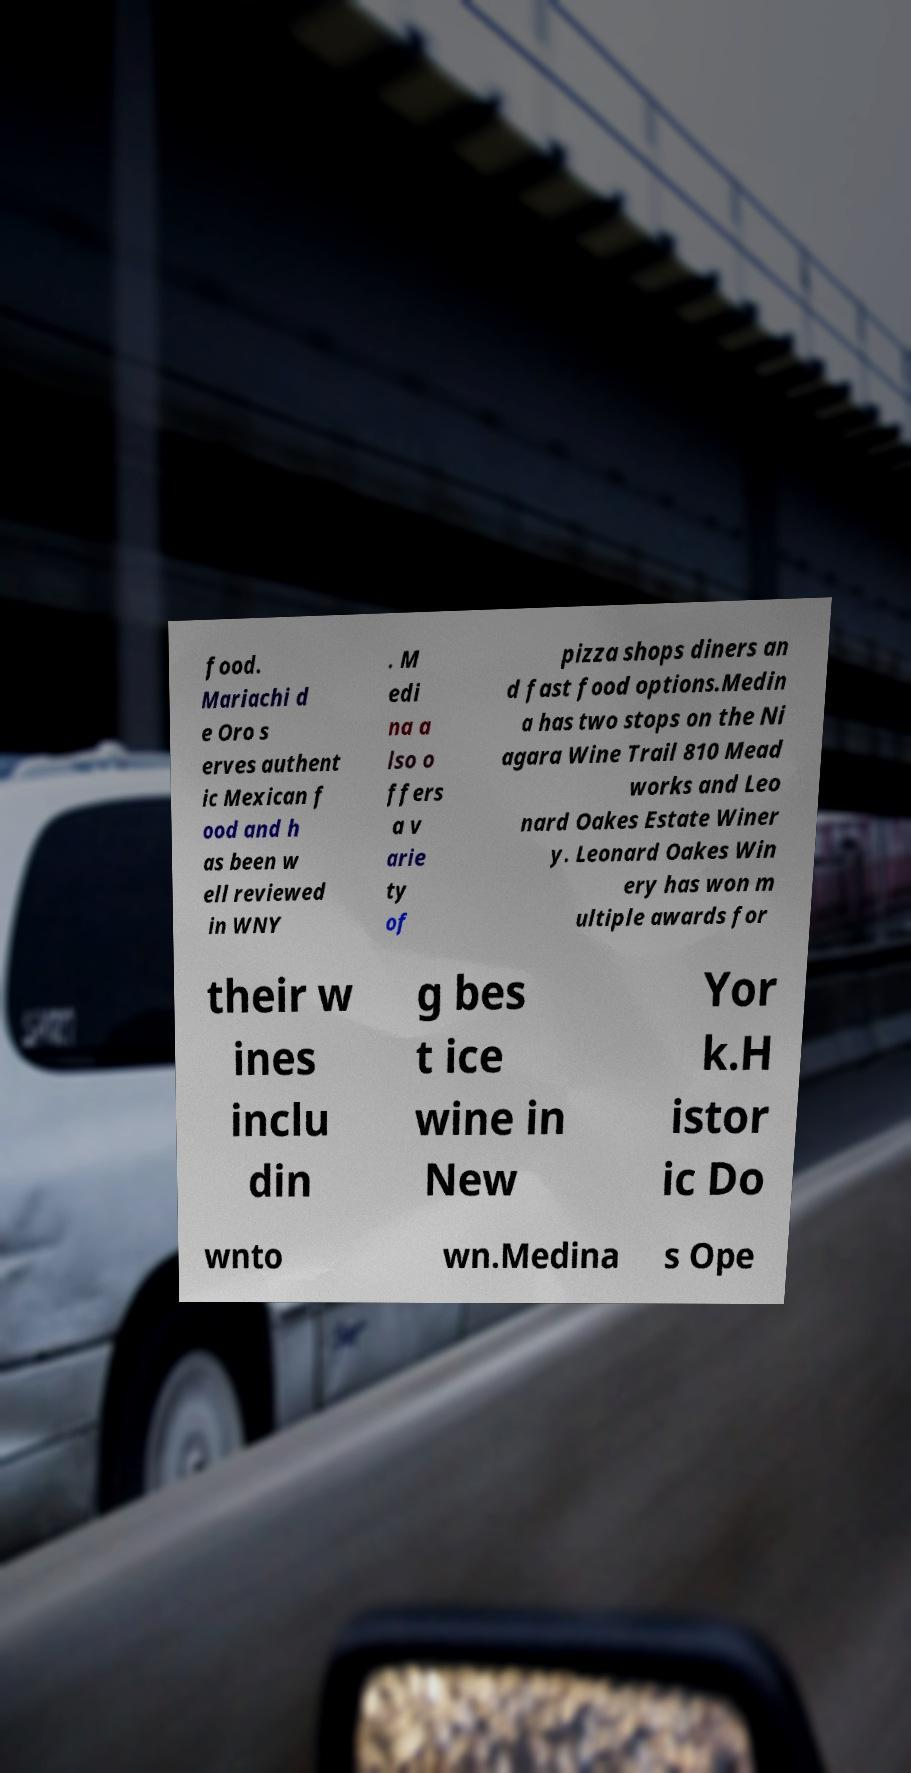Can you accurately transcribe the text from the provided image for me? food. Mariachi d e Oro s erves authent ic Mexican f ood and h as been w ell reviewed in WNY . M edi na a lso o ffers a v arie ty of pizza shops diners an d fast food options.Medin a has two stops on the Ni agara Wine Trail 810 Mead works and Leo nard Oakes Estate Winer y. Leonard Oakes Win ery has won m ultiple awards for their w ines inclu din g bes t ice wine in New Yor k.H istor ic Do wnto wn.Medina s Ope 